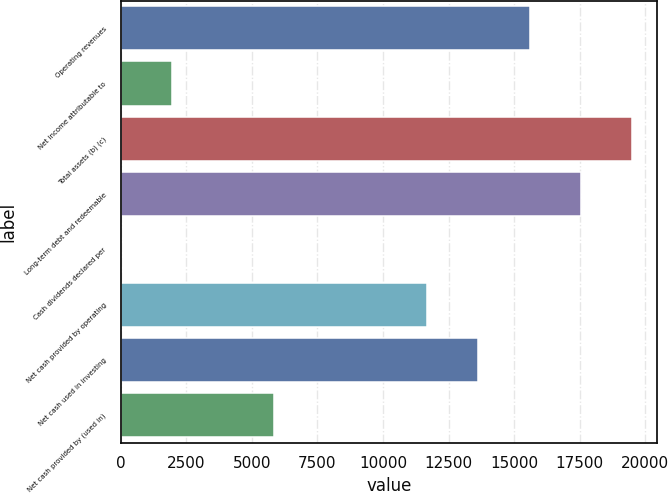Convert chart. <chart><loc_0><loc_0><loc_500><loc_500><bar_chart><fcel>Operating revenues<fcel>Net income attributable to<fcel>Total assets (b) (c)<fcel>Long-term debt and redeemable<fcel>Cash dividends declared per<fcel>Net cash provided by operating<fcel>Net cash used in investing<fcel>Net cash provided by (used in)<nl><fcel>15585.9<fcel>1949.69<fcel>19482<fcel>17533.9<fcel>1.66<fcel>11689.8<fcel>13637.9<fcel>5845.75<nl></chart> 